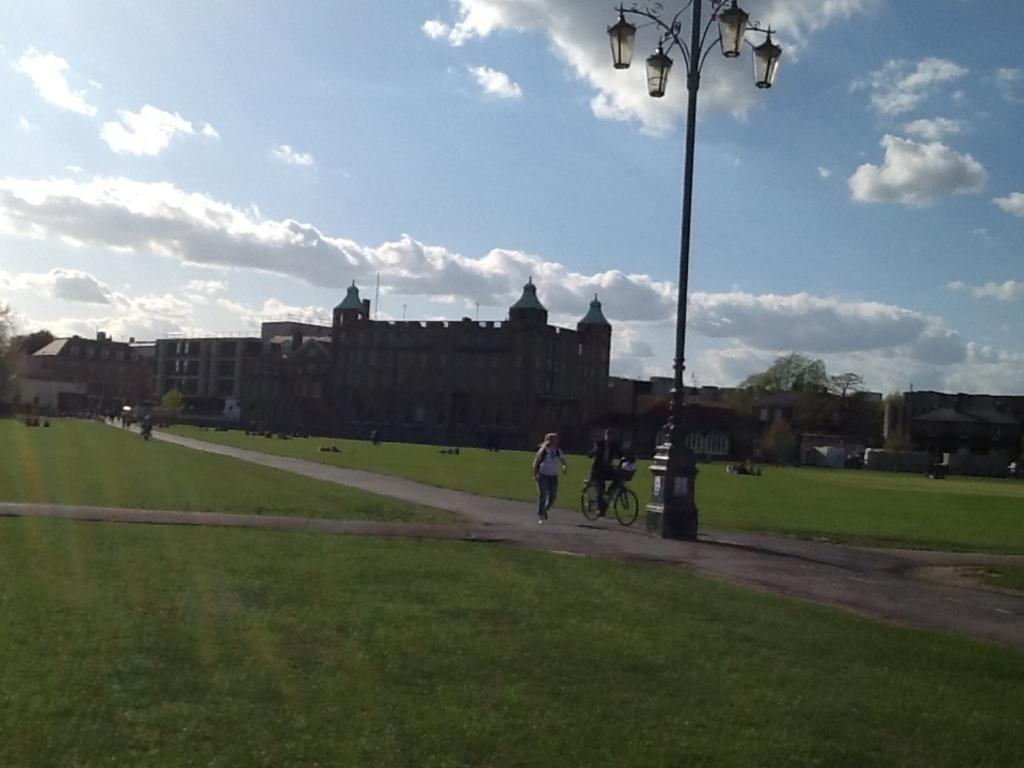How would you summarize this image in a sentence or two? This image is taken outdoors. At the top of the image there is the sky with clouds. At the bottom of the image there is a ground with grass on it. In the background there are a few buildings and houses. There are a few trees and plants. There are a few people. In the middle of the image there is a pole with four street lights. A person is riding on the bicycle and a person is walking on the road. 